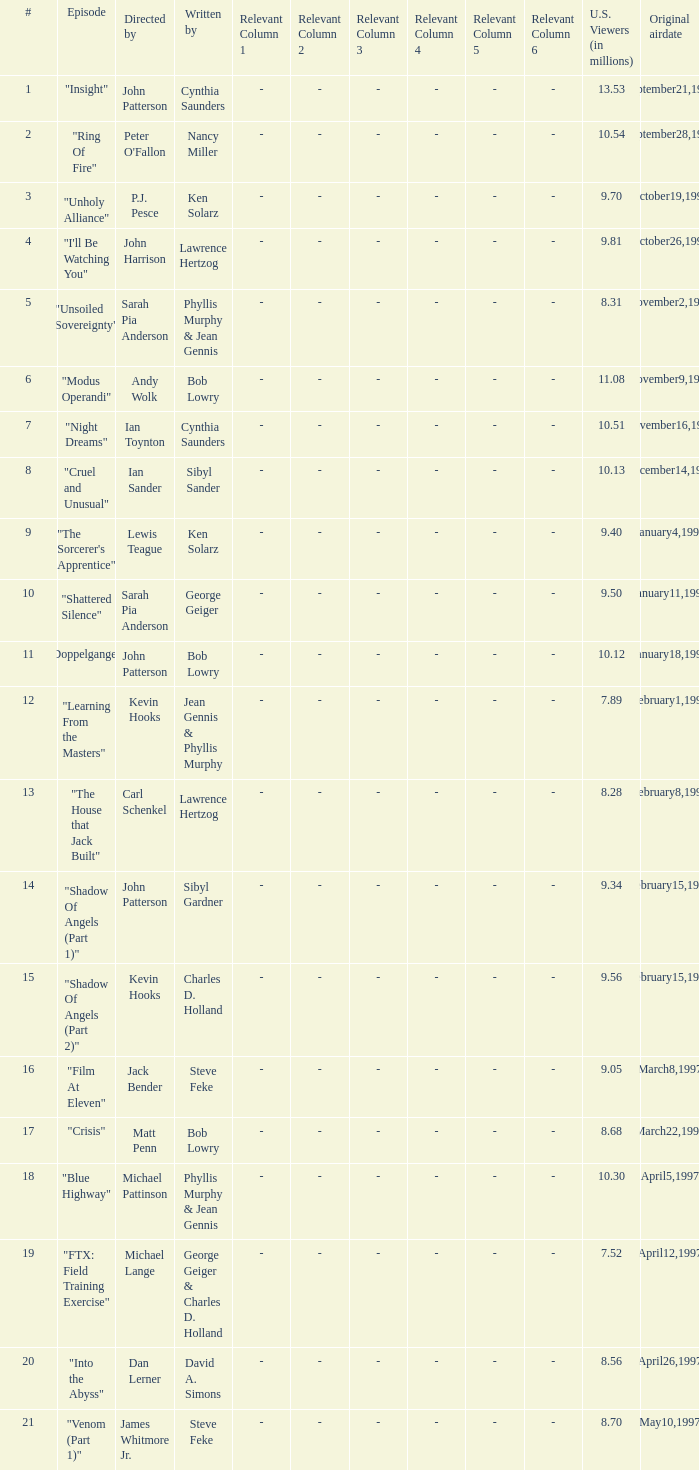Who wrote the episode with 9.81 million US viewers? Lawrence Hertzog. 